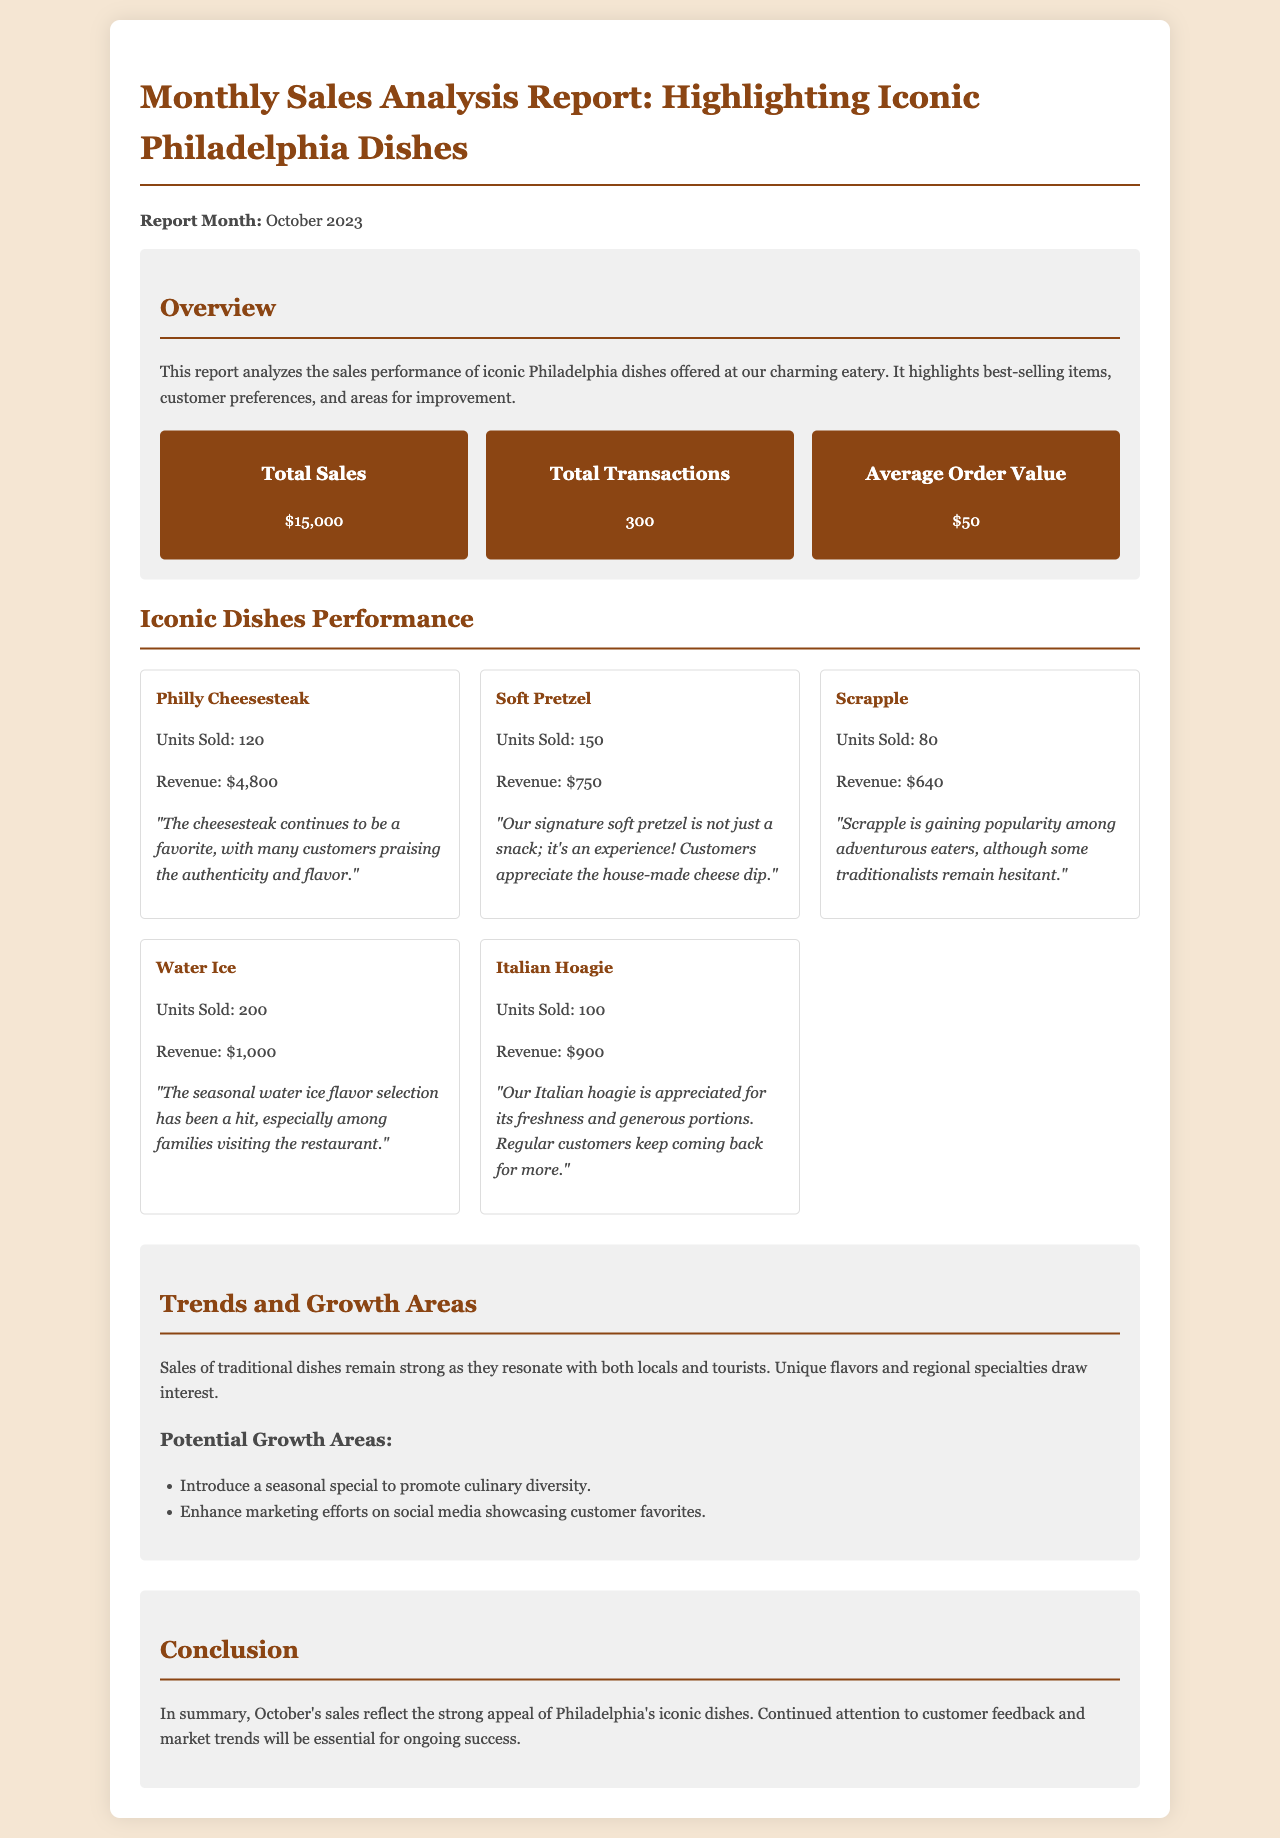What is the total sales amount for October 2023? The total sales amount is stated in the overview section of the report.
Answer: $15,000 How many total transactions occurred in October 2023? The total transactions are provided in the sales summary section.
Answer: 300 What is the average order value in October 2023? The average order value can be found in the overview under sales summary.
Answer: $50 Which iconic dish sold the most units? The iconic dish with the highest units sold is highlighted in the dishes performance section.
Answer: Soft Pretzel What revenue did the Philly Cheesesteak generate? The revenue figure for the Philly Cheesesteak is directly mentioned in its performance card.
Answer: $4,800 What were the potential growth areas identified in the report? The potential growth areas are listed under the trends and growth areas section.
Answer: Seasonal special, social media marketing What is the primary conclusion of the report? The conclusion summarizes the report's findings about Philadelphia's iconic dishes and business performance.
Answer: Strong appeal of Philadelphia's iconic dishes What is the most sold dish with outdoor significance? This can be inferred by looking at the units sold and considering local cultural dishes.
Answer: Water Ice How many units of Scrapple were sold? The information about units sold for Scrapple is available in the dishes performance section.
Answer: 80 